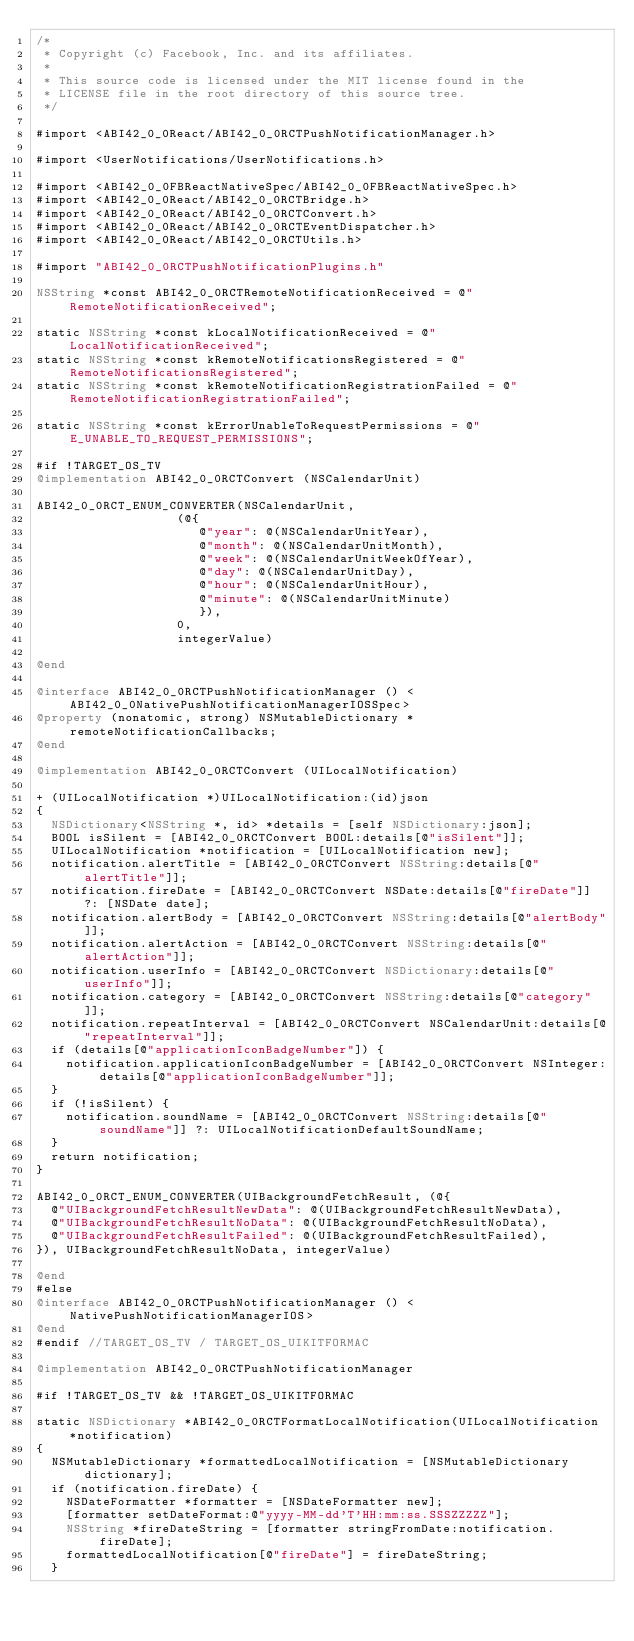Convert code to text. <code><loc_0><loc_0><loc_500><loc_500><_ObjectiveC_>/*
 * Copyright (c) Facebook, Inc. and its affiliates.
 *
 * This source code is licensed under the MIT license found in the
 * LICENSE file in the root directory of this source tree.
 */

#import <ABI42_0_0React/ABI42_0_0RCTPushNotificationManager.h>

#import <UserNotifications/UserNotifications.h>

#import <ABI42_0_0FBReactNativeSpec/ABI42_0_0FBReactNativeSpec.h>
#import <ABI42_0_0React/ABI42_0_0RCTBridge.h>
#import <ABI42_0_0React/ABI42_0_0RCTConvert.h>
#import <ABI42_0_0React/ABI42_0_0RCTEventDispatcher.h>
#import <ABI42_0_0React/ABI42_0_0RCTUtils.h>

#import "ABI42_0_0RCTPushNotificationPlugins.h"

NSString *const ABI42_0_0RCTRemoteNotificationReceived = @"RemoteNotificationReceived";

static NSString *const kLocalNotificationReceived = @"LocalNotificationReceived";
static NSString *const kRemoteNotificationsRegistered = @"RemoteNotificationsRegistered";
static NSString *const kRemoteNotificationRegistrationFailed = @"RemoteNotificationRegistrationFailed";

static NSString *const kErrorUnableToRequestPermissions = @"E_UNABLE_TO_REQUEST_PERMISSIONS";

#if !TARGET_OS_TV
@implementation ABI42_0_0RCTConvert (NSCalendarUnit)

ABI42_0_0RCT_ENUM_CONVERTER(NSCalendarUnit,
                   (@{
                      @"year": @(NSCalendarUnitYear),
                      @"month": @(NSCalendarUnitMonth),
                      @"week": @(NSCalendarUnitWeekOfYear),
                      @"day": @(NSCalendarUnitDay),
                      @"hour": @(NSCalendarUnitHour),
                      @"minute": @(NSCalendarUnitMinute)
                      }),
                   0,
                   integerValue)

@end

@interface ABI42_0_0RCTPushNotificationManager () <ABI42_0_0NativePushNotificationManagerIOSSpec>
@property (nonatomic, strong) NSMutableDictionary *remoteNotificationCallbacks;
@end

@implementation ABI42_0_0RCTConvert (UILocalNotification)

+ (UILocalNotification *)UILocalNotification:(id)json
{
  NSDictionary<NSString *, id> *details = [self NSDictionary:json];
  BOOL isSilent = [ABI42_0_0RCTConvert BOOL:details[@"isSilent"]];
  UILocalNotification *notification = [UILocalNotification new];
  notification.alertTitle = [ABI42_0_0RCTConvert NSString:details[@"alertTitle"]];
  notification.fireDate = [ABI42_0_0RCTConvert NSDate:details[@"fireDate"]] ?: [NSDate date];
  notification.alertBody = [ABI42_0_0RCTConvert NSString:details[@"alertBody"]];
  notification.alertAction = [ABI42_0_0RCTConvert NSString:details[@"alertAction"]];
  notification.userInfo = [ABI42_0_0RCTConvert NSDictionary:details[@"userInfo"]];
  notification.category = [ABI42_0_0RCTConvert NSString:details[@"category"]];
  notification.repeatInterval = [ABI42_0_0RCTConvert NSCalendarUnit:details[@"repeatInterval"]];
  if (details[@"applicationIconBadgeNumber"]) {
    notification.applicationIconBadgeNumber = [ABI42_0_0RCTConvert NSInteger:details[@"applicationIconBadgeNumber"]];
  }
  if (!isSilent) {
    notification.soundName = [ABI42_0_0RCTConvert NSString:details[@"soundName"]] ?: UILocalNotificationDefaultSoundName;
  }
  return notification;
}

ABI42_0_0RCT_ENUM_CONVERTER(UIBackgroundFetchResult, (@{
  @"UIBackgroundFetchResultNewData": @(UIBackgroundFetchResultNewData),
  @"UIBackgroundFetchResultNoData": @(UIBackgroundFetchResultNoData),
  @"UIBackgroundFetchResultFailed": @(UIBackgroundFetchResultFailed),
}), UIBackgroundFetchResultNoData, integerValue)

@end
#else
@interface ABI42_0_0RCTPushNotificationManager () <NativePushNotificationManagerIOS>
@end
#endif //TARGET_OS_TV / TARGET_OS_UIKITFORMAC

@implementation ABI42_0_0RCTPushNotificationManager

#if !TARGET_OS_TV && !TARGET_OS_UIKITFORMAC

static NSDictionary *ABI42_0_0RCTFormatLocalNotification(UILocalNotification *notification)
{
  NSMutableDictionary *formattedLocalNotification = [NSMutableDictionary dictionary];
  if (notification.fireDate) {
    NSDateFormatter *formatter = [NSDateFormatter new];
    [formatter setDateFormat:@"yyyy-MM-dd'T'HH:mm:ss.SSSZZZZZ"];
    NSString *fireDateString = [formatter stringFromDate:notification.fireDate];
    formattedLocalNotification[@"fireDate"] = fireDateString;
  }</code> 